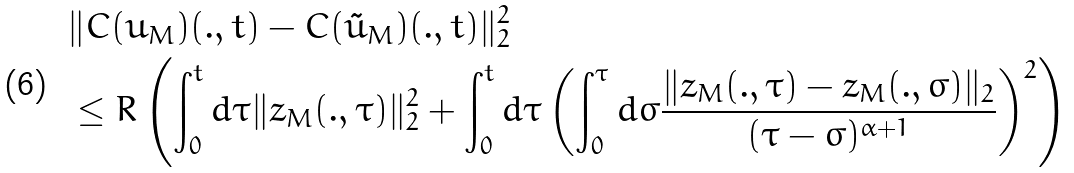Convert formula to latex. <formula><loc_0><loc_0><loc_500><loc_500>& \| C ( u _ { M } ) ( . , t ) - C ( \tilde { u } _ { M } ) ( . , t ) \| _ { 2 } ^ { 2 } \\ & \leq R \left ( \int _ { 0 } ^ { t } d \tau \| z _ { M } ( . , \tau ) \| _ { 2 } ^ { 2 } + \int _ { 0 } ^ { t } d \tau \left ( \int _ { 0 } ^ { \tau } d \sigma \frac { \| z _ { M } ( . , \tau ) - z _ { M } ( . , \sigma ) \| _ { 2 } } { ( \tau - \sigma ) ^ { \alpha + 1 } } \right ) ^ { 2 } \right )</formula> 